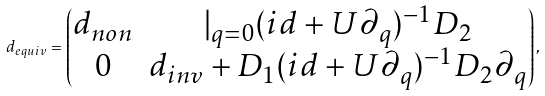<formula> <loc_0><loc_0><loc_500><loc_500>d _ { e q u i v } = \begin{pmatrix} d _ { n o n } & | _ { q = 0 } ( i d + U \partial _ { q } ) ^ { - 1 } D _ { 2 } \\ 0 & d _ { i n v } + D _ { 1 } ( i d + U \partial _ { q } ) ^ { - 1 } D _ { 2 } \partial _ { q } \end{pmatrix} ,</formula> 